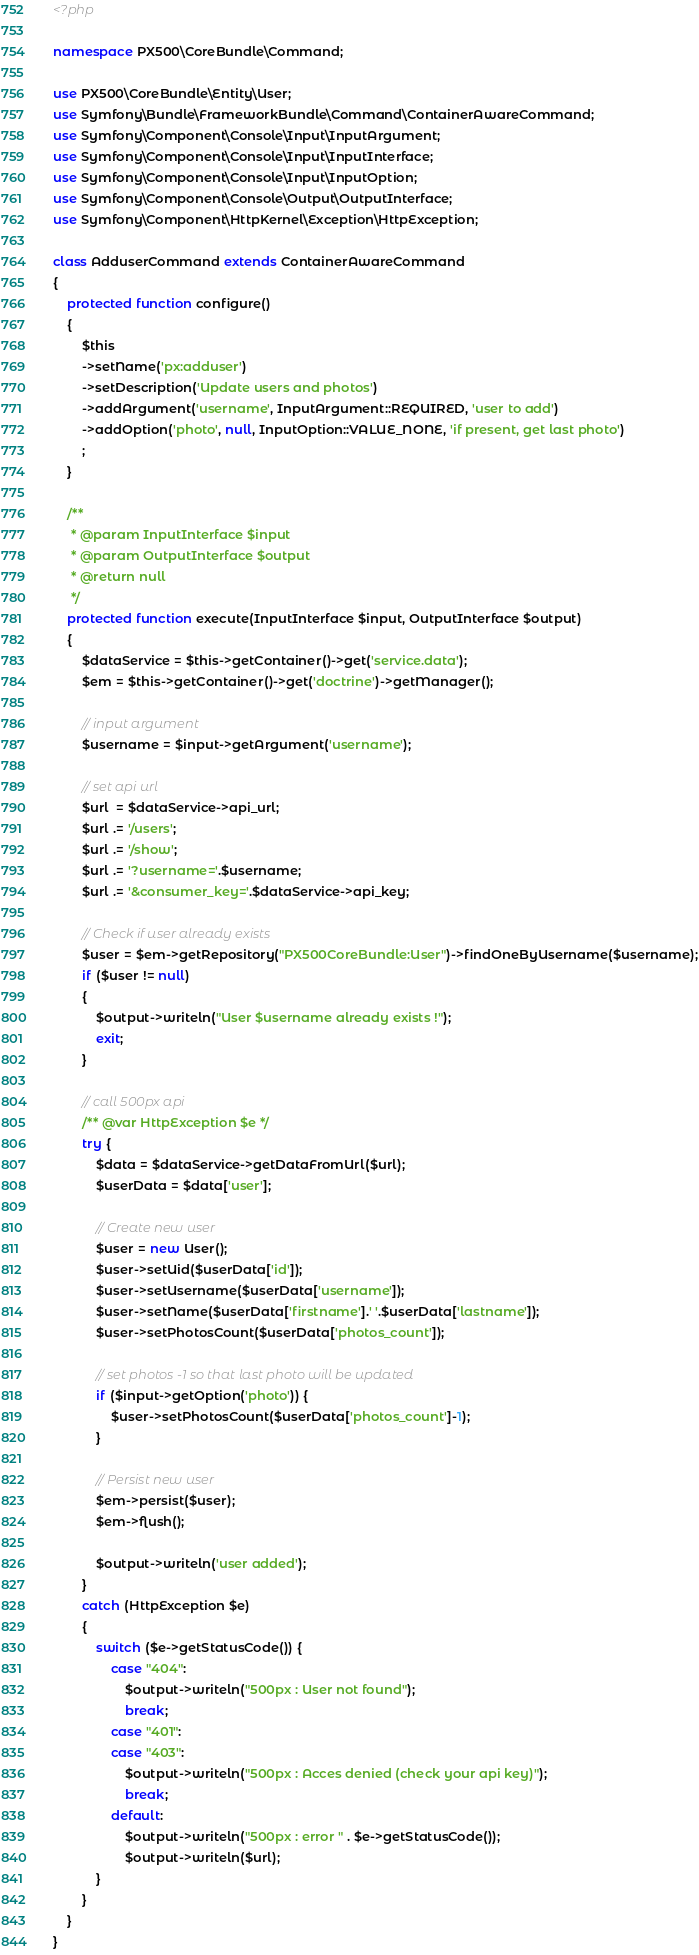<code> <loc_0><loc_0><loc_500><loc_500><_PHP_><?php

namespace PX500\CoreBundle\Command;

use PX500\CoreBundle\Entity\User;
use Symfony\Bundle\FrameworkBundle\Command\ContainerAwareCommand;
use Symfony\Component\Console\Input\InputArgument;
use Symfony\Component\Console\Input\InputInterface;
use Symfony\Component\Console\Input\InputOption;
use Symfony\Component\Console\Output\OutputInterface;
use Symfony\Component\HttpKernel\Exception\HttpException;

class AdduserCommand extends ContainerAwareCommand
{
    protected function configure()
    {
        $this
        ->setName('px:adduser')
        ->setDescription('Update users and photos')
        ->addArgument('username', InputArgument::REQUIRED, 'user to add')
        ->addOption('photo', null, InputOption::VALUE_NONE, 'if present, get last photo')
        ;
    }

    /**
     * @param InputInterface $input
     * @param OutputInterface $output
     * @return null
     */
    protected function execute(InputInterface $input, OutputInterface $output)
    {
        $dataService = $this->getContainer()->get('service.data');
        $em = $this->getContainer()->get('doctrine')->getManager();

        // input argument
        $username = $input->getArgument('username');

        // set api url
        $url  = $dataService->api_url;
        $url .= '/users';
        $url .= '/show';
        $url .= '?username='.$username;
        $url .= '&consumer_key='.$dataService->api_key;

        // Check if user already exists
        $user = $em->getRepository("PX500CoreBundle:User")->findOneByUsername($username);
        if ($user != null)
        {
            $output->writeln("User $username already exists !");
            exit;
        }

        // call 500px api
        /** @var HttpException $e */
        try {
            $data = $dataService->getDataFromUrl($url);
            $userData = $data['user'];

            // Create new user
            $user = new User();
            $user->setUid($userData['id']);
            $user->setUsername($userData['username']);
            $user->setName($userData['firstname'].' '.$userData['lastname']);
            $user->setPhotosCount($userData['photos_count']);

            // set photos -1 so that last photo will be updated
            if ($input->getOption('photo')) {
                $user->setPhotosCount($userData['photos_count']-1);
            }

            // Persist new user
            $em->persist($user);
            $em->flush();

            $output->writeln('user added');
        }
        catch (HttpException $e)
        {
            switch ($e->getStatusCode()) {
                case "404":
                    $output->writeln("500px : User not found");
                    break;
                case "401":
                case "403":
                    $output->writeln("500px : Acces denied (check your api key)");
                    break;
                default:
                    $output->writeln("500px : error " . $e->getStatusCode());
                    $output->writeln($url);
            }
        }
    }
}</code> 